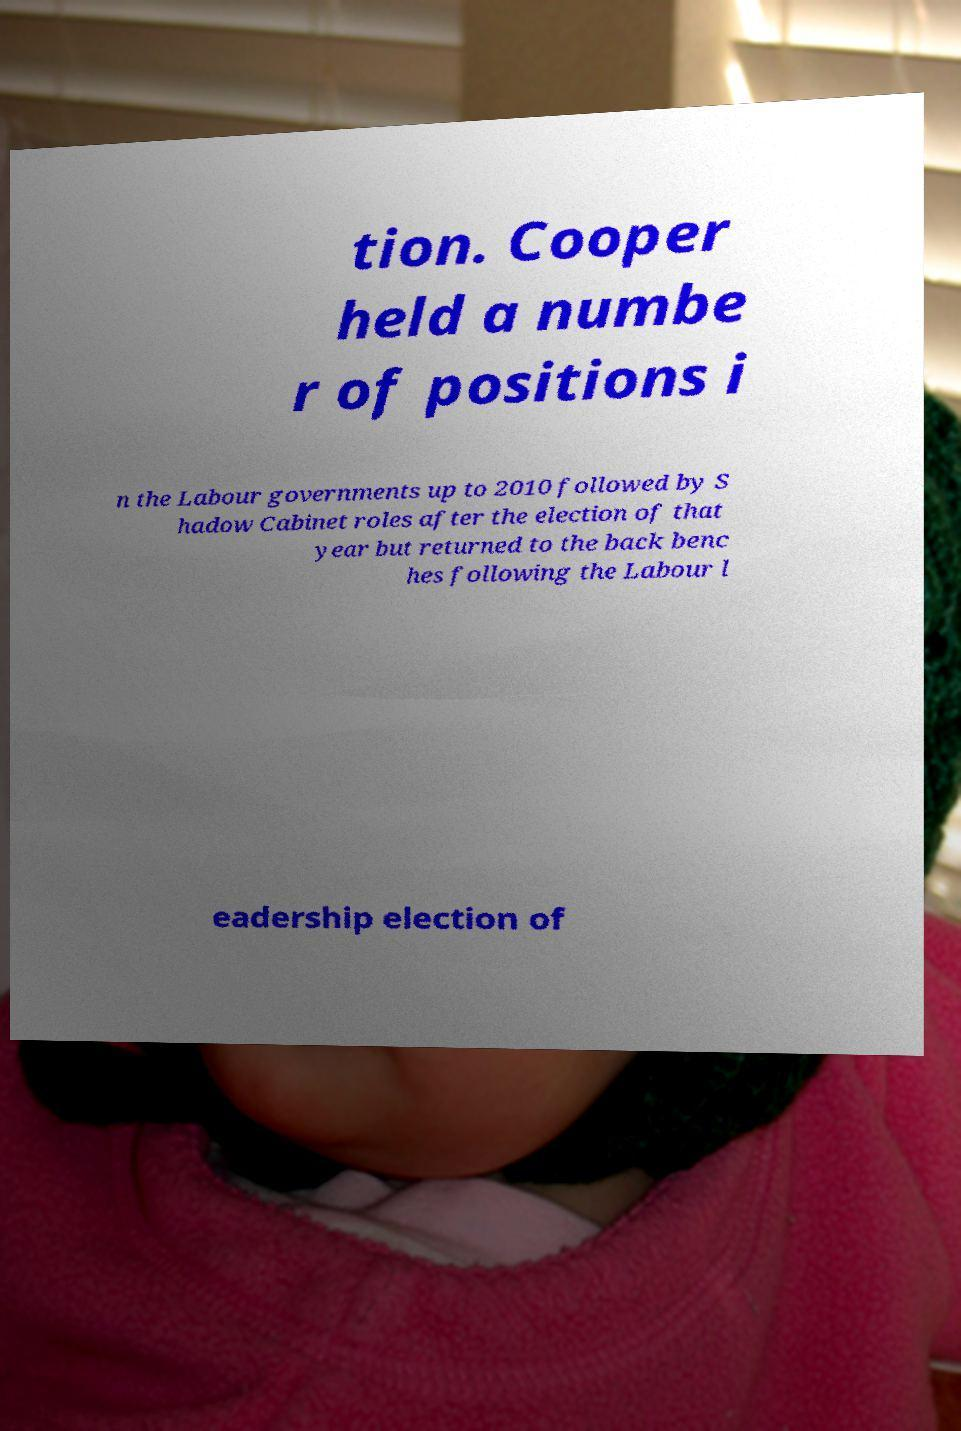Please identify and transcribe the text found in this image. tion. Cooper held a numbe r of positions i n the Labour governments up to 2010 followed by S hadow Cabinet roles after the election of that year but returned to the back benc hes following the Labour l eadership election of 